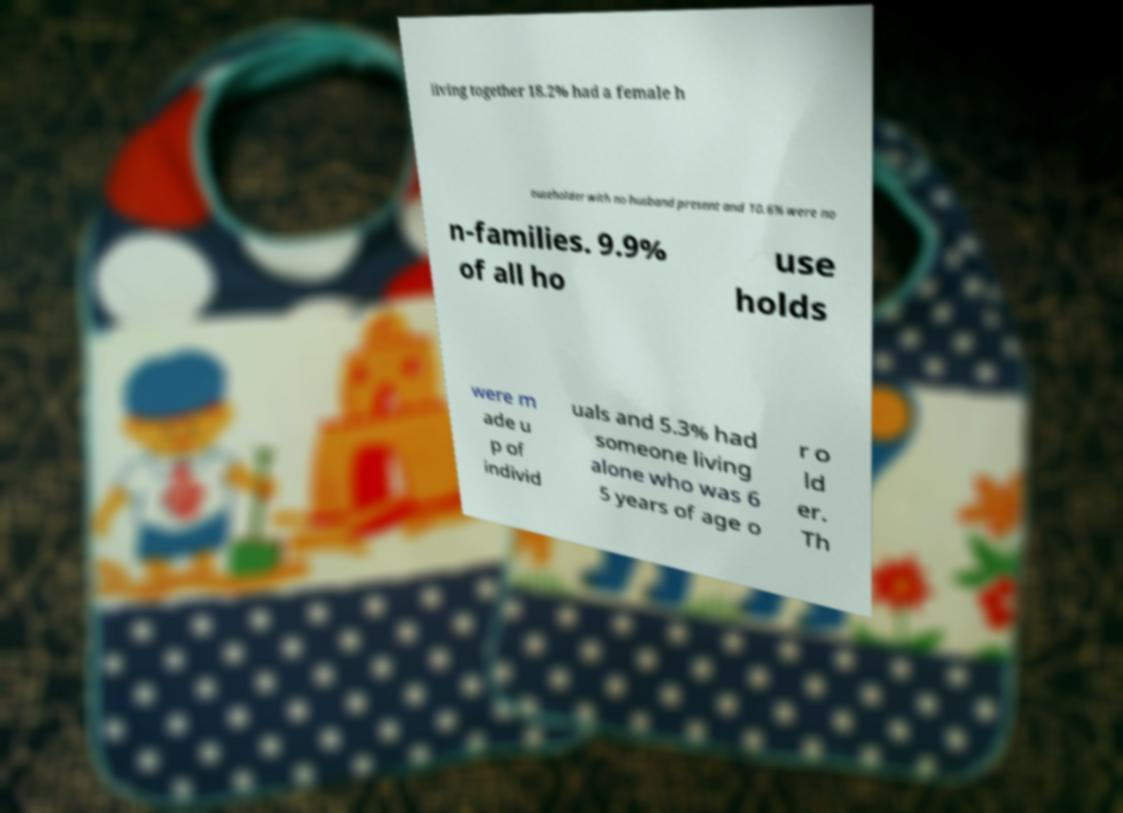For documentation purposes, I need the text within this image transcribed. Could you provide that? living together 18.2% had a female h ouseholder with no husband present and 10.6% were no n-families. 9.9% of all ho use holds were m ade u p of individ uals and 5.3% had someone living alone who was 6 5 years of age o r o ld er. Th 